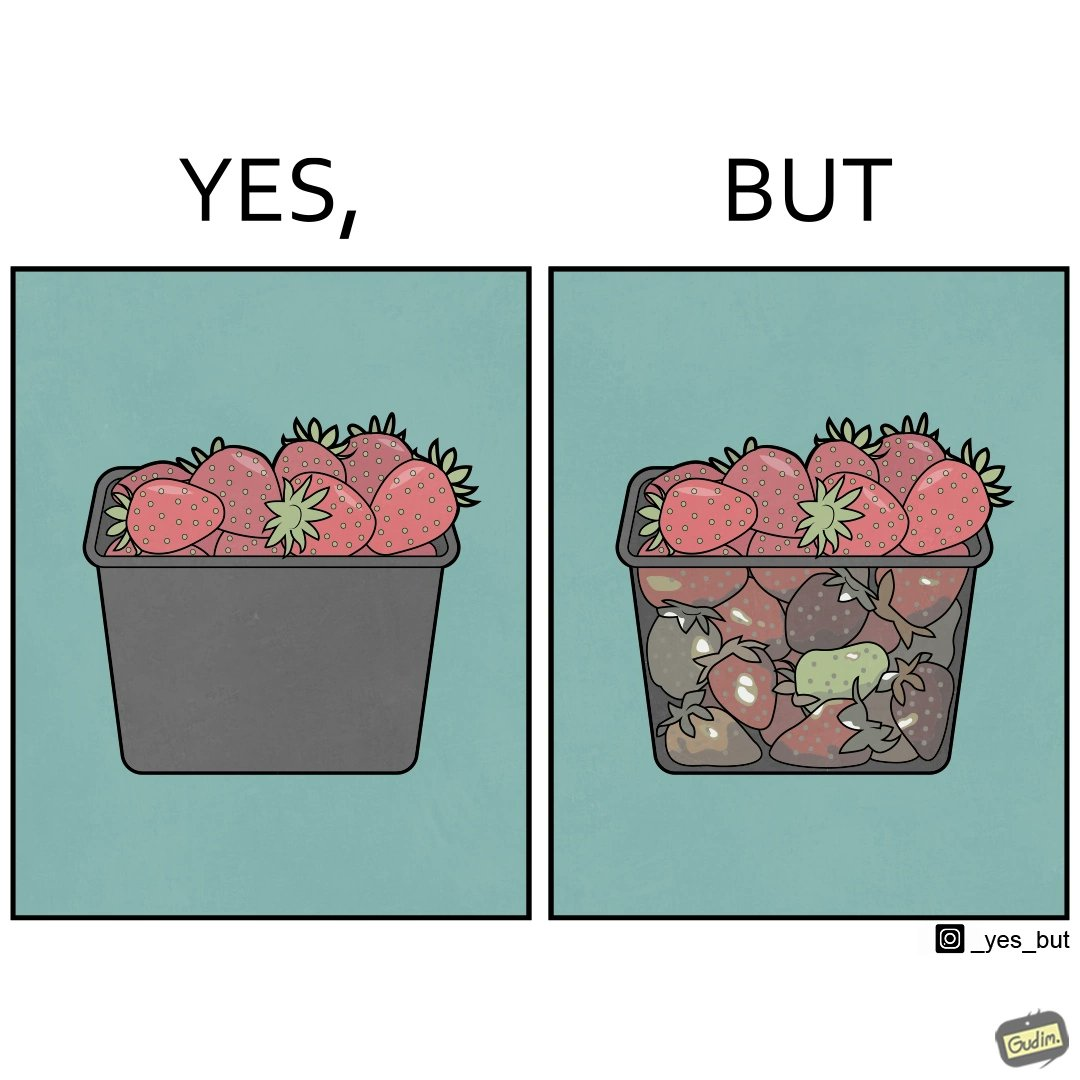Why is this image considered satirical? the image is funny, as the strawberries in a container generally bought in retail appear fresh from the top, but the ones below them (which are generally not visible directly while buying the container of strawberries) are low quality/spoilt, revealing the tactics that retail uses to pass on low-quality products to innocent consumers. 